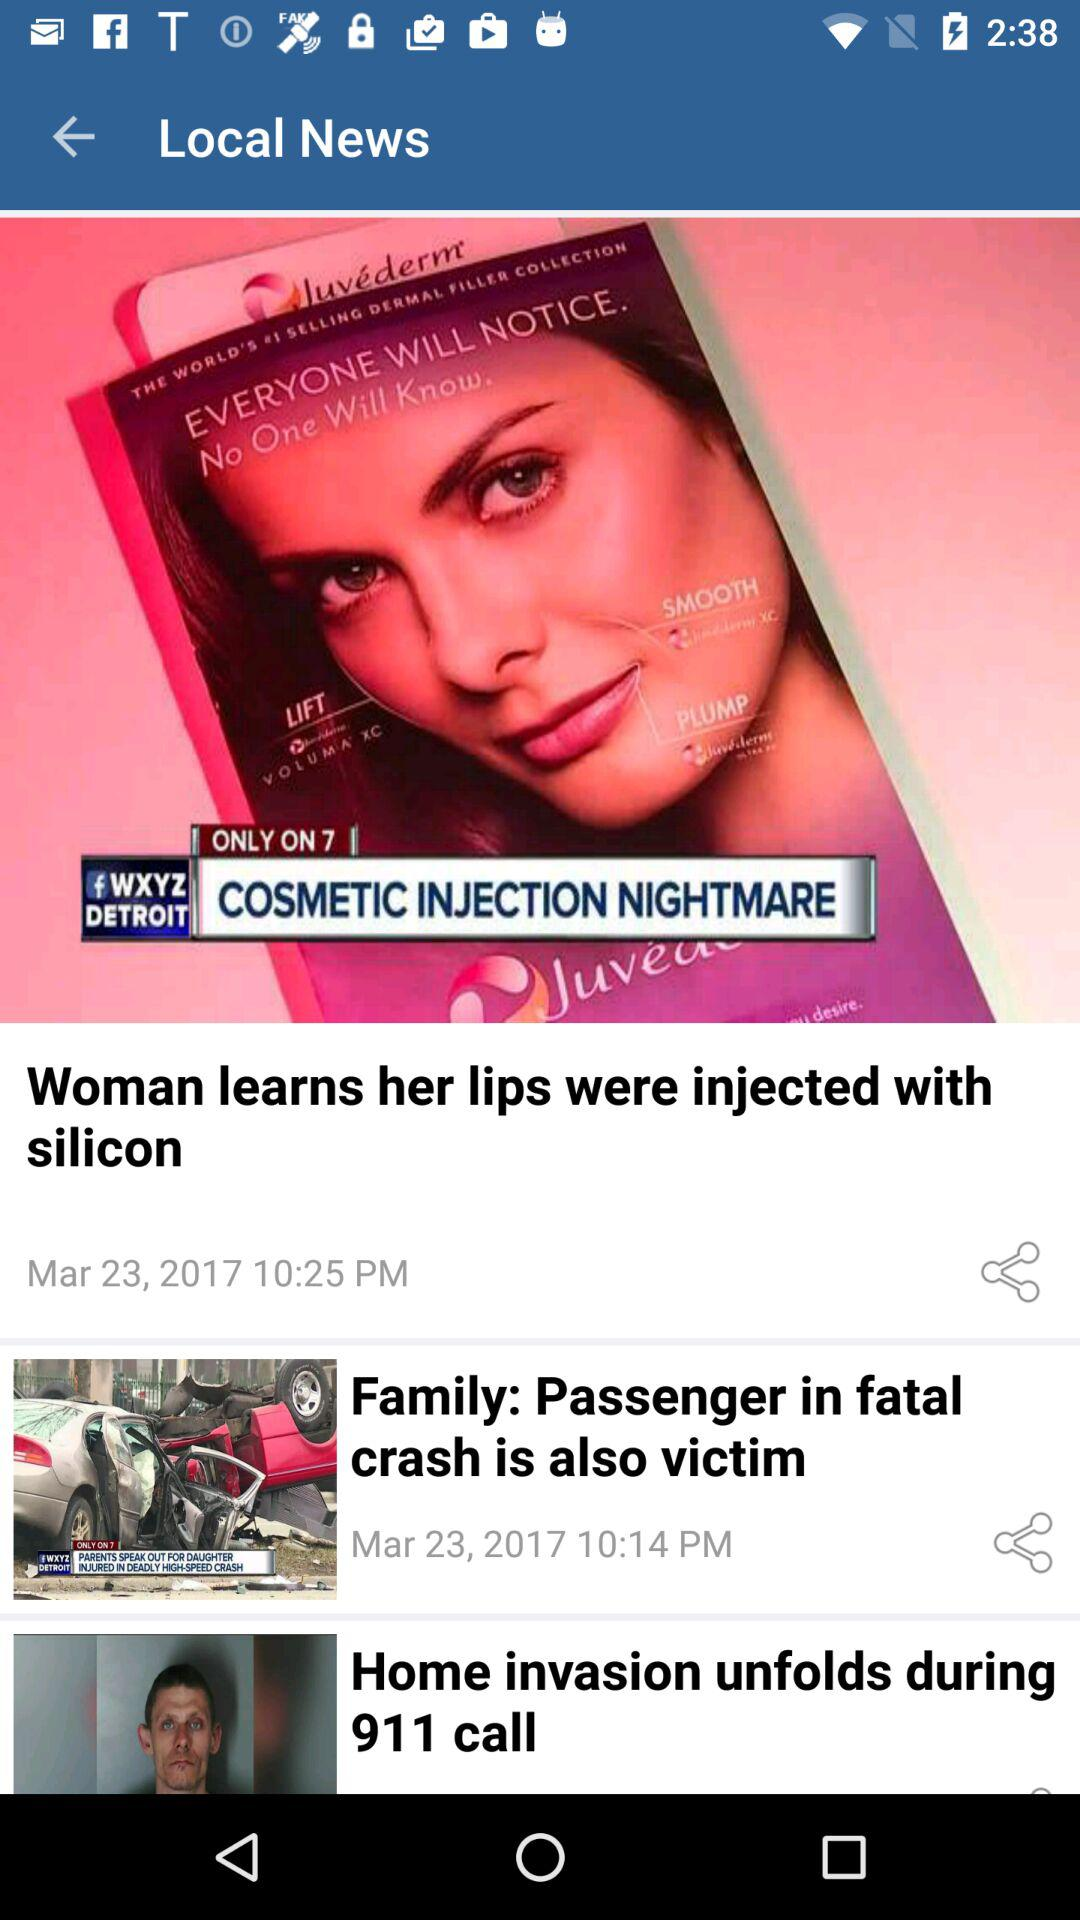What is the posted time of the news "Woman learns her lips were injected with silicon"? The posted time is 10:00 PM. 